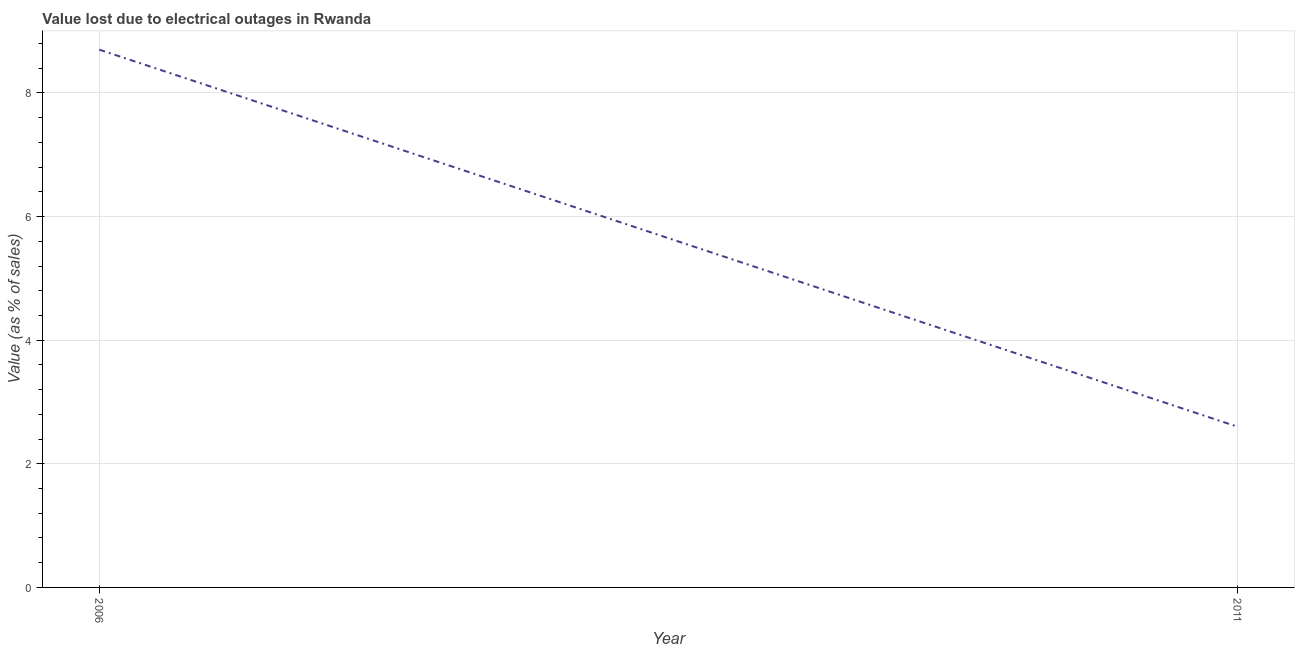What is the value lost due to electrical outages in 2011?
Offer a terse response. 2.6. Across all years, what is the minimum value lost due to electrical outages?
Give a very brief answer. 2.6. In which year was the value lost due to electrical outages maximum?
Make the answer very short. 2006. What is the sum of the value lost due to electrical outages?
Keep it short and to the point. 11.3. What is the average value lost due to electrical outages per year?
Provide a succinct answer. 5.65. What is the median value lost due to electrical outages?
Your answer should be compact. 5.65. In how many years, is the value lost due to electrical outages greater than 5.2 %?
Offer a terse response. 1. What is the ratio of the value lost due to electrical outages in 2006 to that in 2011?
Make the answer very short. 3.35. Is the value lost due to electrical outages in 2006 less than that in 2011?
Your answer should be very brief. No. In how many years, is the value lost due to electrical outages greater than the average value lost due to electrical outages taken over all years?
Your answer should be compact. 1. Does the value lost due to electrical outages monotonically increase over the years?
Give a very brief answer. No. How many lines are there?
Your answer should be compact. 1. What is the difference between two consecutive major ticks on the Y-axis?
Your response must be concise. 2. Are the values on the major ticks of Y-axis written in scientific E-notation?
Your answer should be very brief. No. Does the graph contain any zero values?
Keep it short and to the point. No. Does the graph contain grids?
Offer a very short reply. Yes. What is the title of the graph?
Make the answer very short. Value lost due to electrical outages in Rwanda. What is the label or title of the Y-axis?
Give a very brief answer. Value (as % of sales). What is the Value (as % of sales) in 2011?
Your response must be concise. 2.6. What is the difference between the Value (as % of sales) in 2006 and 2011?
Provide a short and direct response. 6.1. What is the ratio of the Value (as % of sales) in 2006 to that in 2011?
Provide a short and direct response. 3.35. 